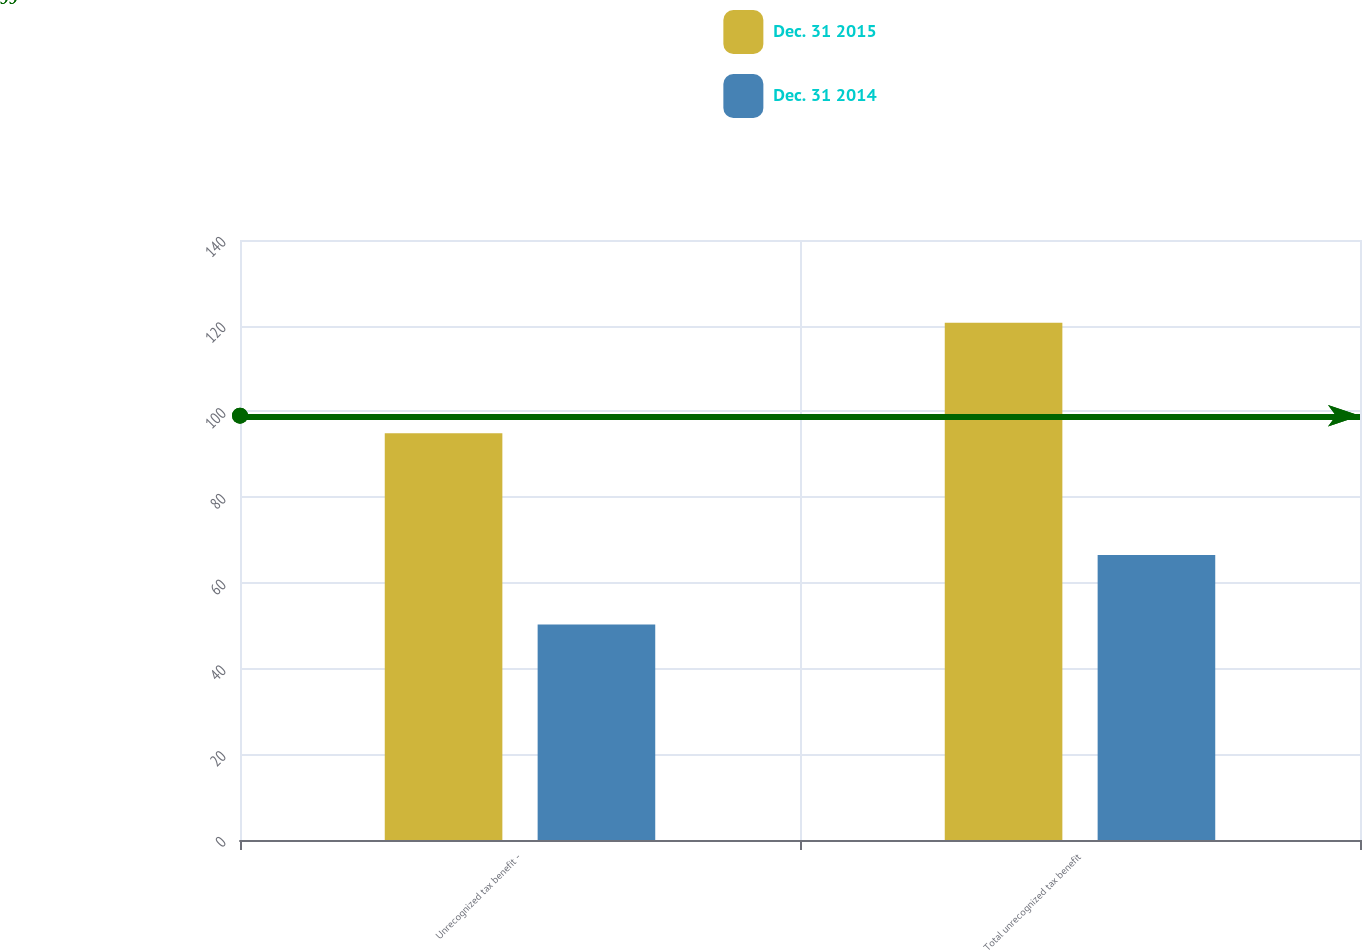Convert chart. <chart><loc_0><loc_0><loc_500><loc_500><stacked_bar_chart><ecel><fcel>Unrecognized tax benefit -<fcel>Total unrecognized tax benefit<nl><fcel>Dec. 31 2015<fcel>94.9<fcel>120.7<nl><fcel>Dec. 31 2014<fcel>50.3<fcel>66.5<nl></chart> 